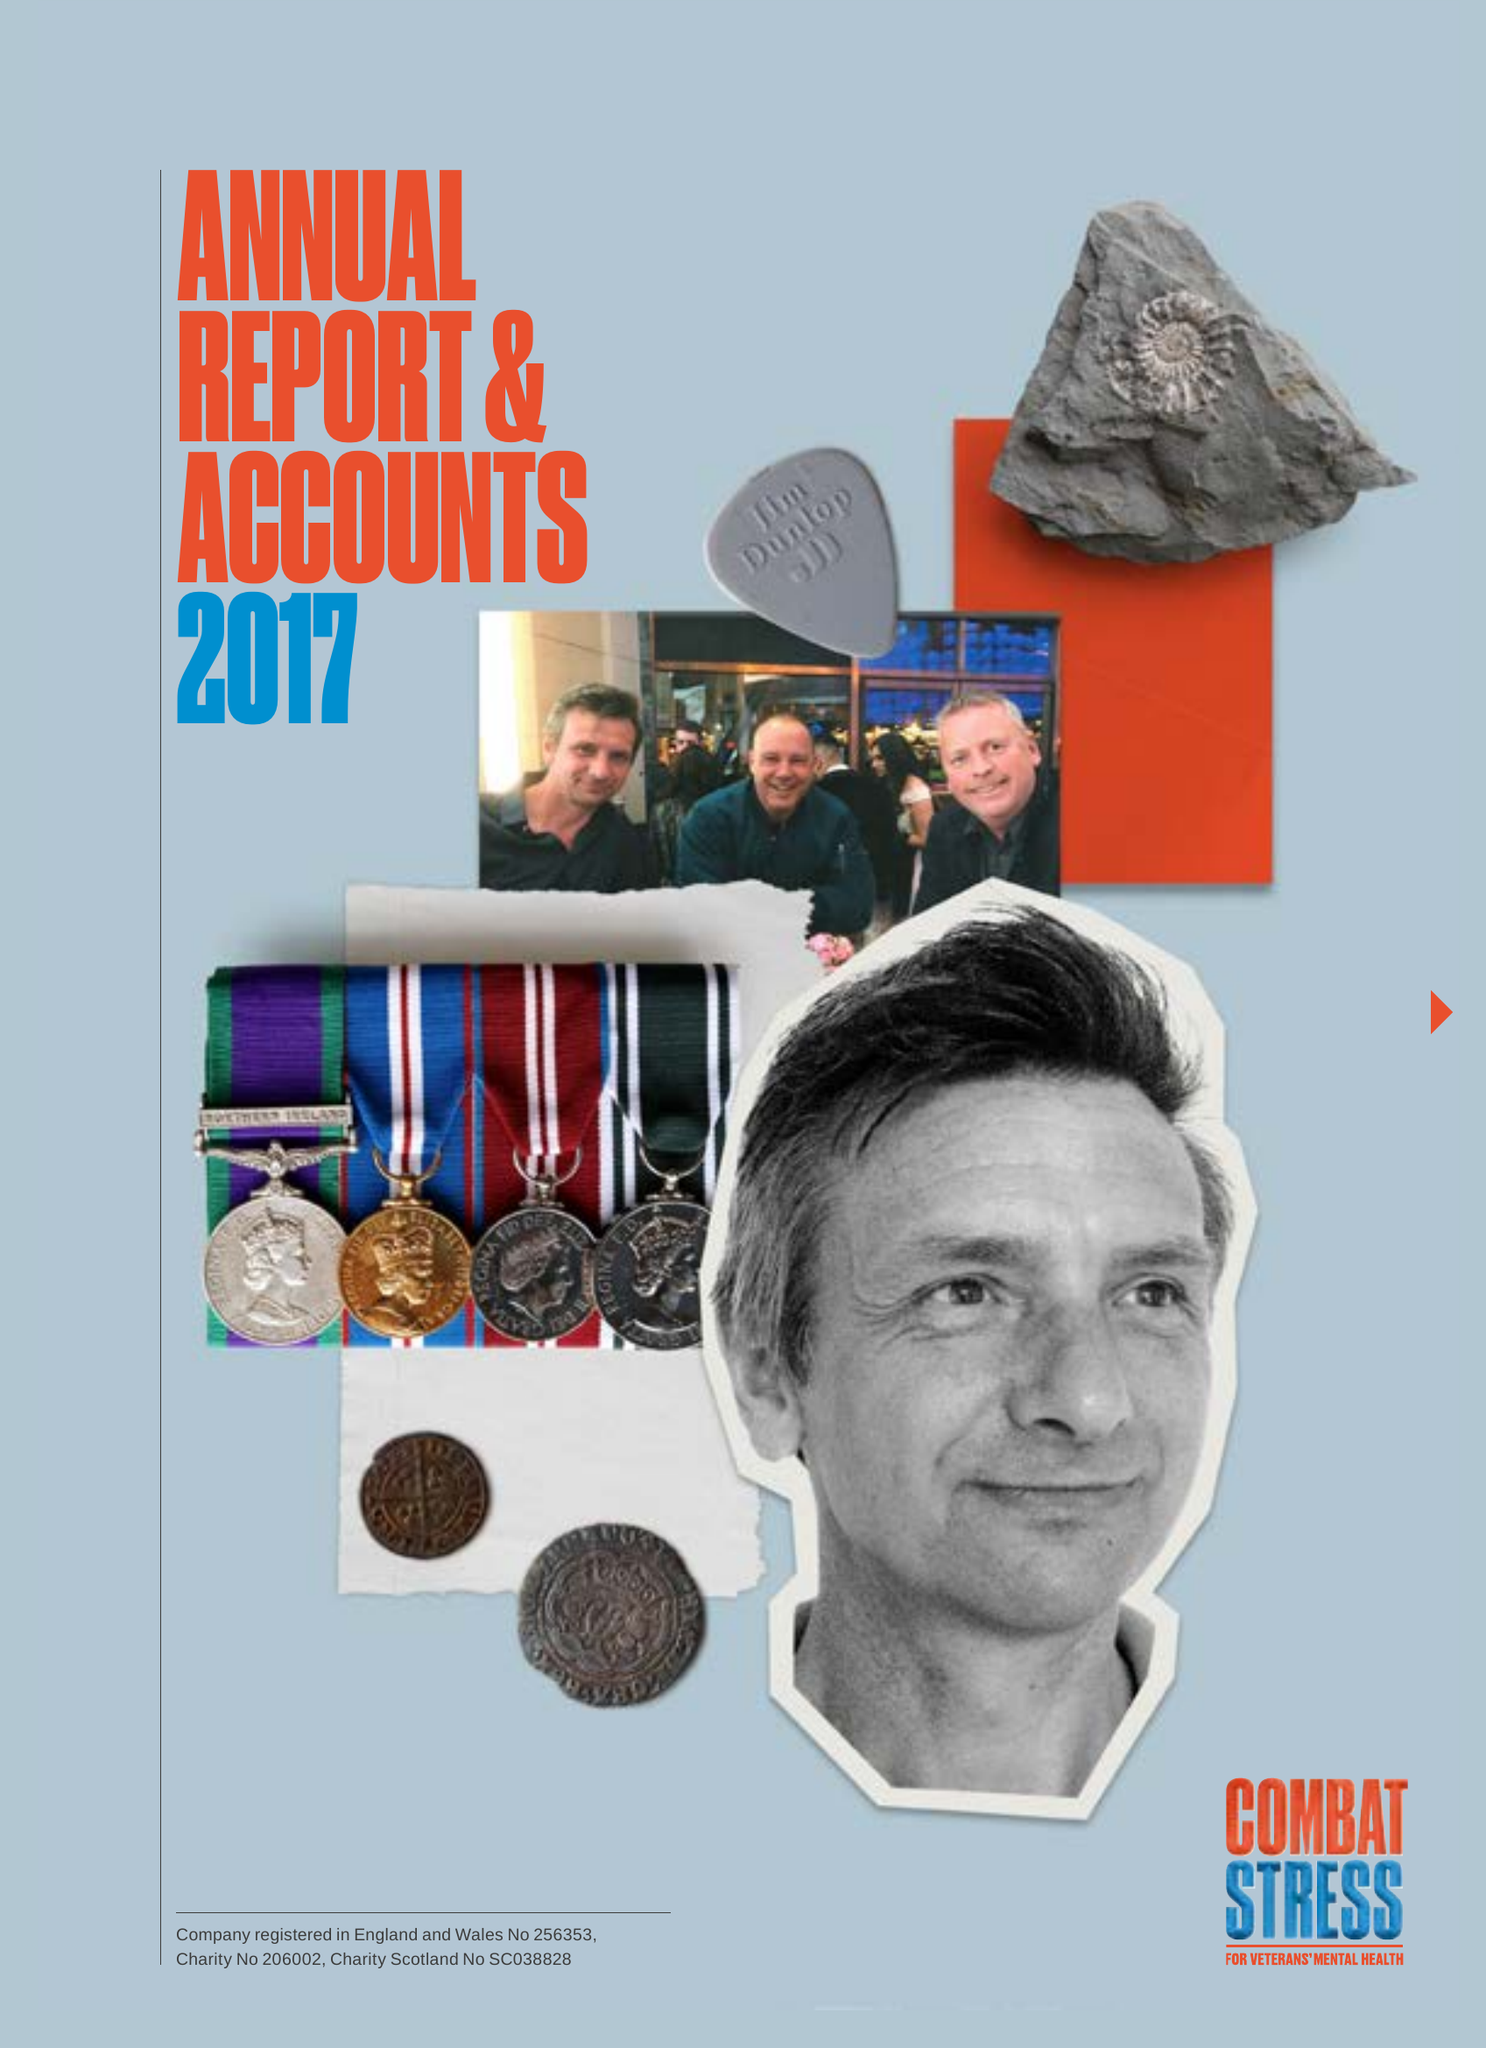What is the value for the spending_annually_in_british_pounds?
Answer the question using a single word or phrase. 17048000.00 